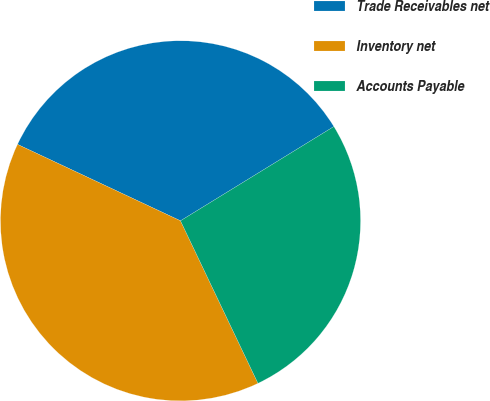Convert chart. <chart><loc_0><loc_0><loc_500><loc_500><pie_chart><fcel>Trade Receivables net<fcel>Inventory net<fcel>Accounts Payable<nl><fcel>34.25%<fcel>39.06%<fcel>26.69%<nl></chart> 